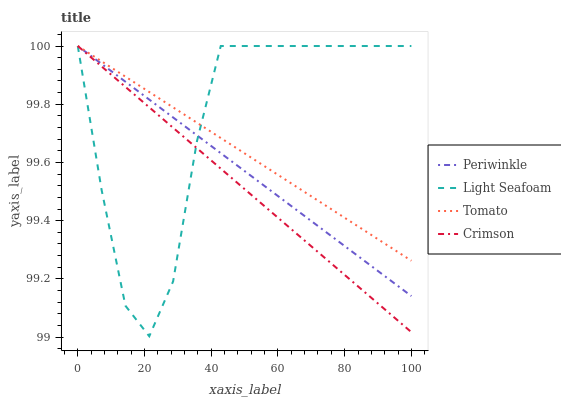Does Crimson have the minimum area under the curve?
Answer yes or no. Yes. Does Light Seafoam have the maximum area under the curve?
Answer yes or no. Yes. Does Light Seafoam have the minimum area under the curve?
Answer yes or no. No. Does Crimson have the maximum area under the curve?
Answer yes or no. No. Is Tomato the smoothest?
Answer yes or no. Yes. Is Light Seafoam the roughest?
Answer yes or no. Yes. Is Crimson the smoothest?
Answer yes or no. No. Is Crimson the roughest?
Answer yes or no. No. Does Light Seafoam have the lowest value?
Answer yes or no. Yes. Does Crimson have the lowest value?
Answer yes or no. No. Does Periwinkle have the highest value?
Answer yes or no. Yes. Does Light Seafoam intersect Crimson?
Answer yes or no. Yes. Is Light Seafoam less than Crimson?
Answer yes or no. No. Is Light Seafoam greater than Crimson?
Answer yes or no. No. 